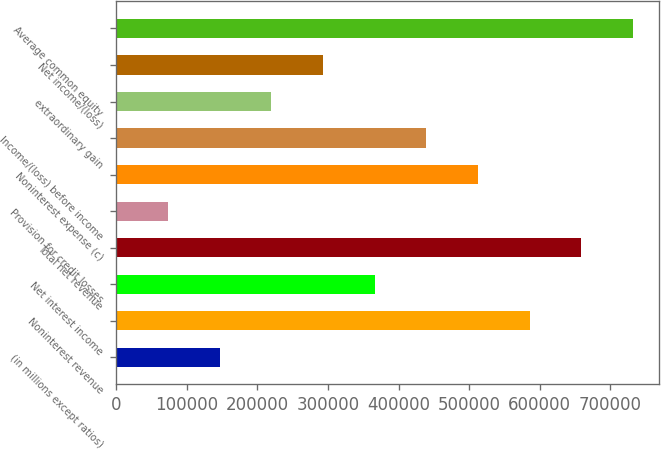<chart> <loc_0><loc_0><loc_500><loc_500><bar_chart><fcel>(in millions except ratios)<fcel>Noninterest revenue<fcel>Net interest income<fcel>Total net revenue<fcel>Provision for credit losses<fcel>Noninterest expense (c)<fcel>Income/(loss) before income<fcel>extraordinary gain<fcel>Net income/(loss)<fcel>Average common equity<nl><fcel>146413<fcel>585454<fcel>365934<fcel>658628<fcel>73239.5<fcel>512280<fcel>439107<fcel>219586<fcel>292760<fcel>731801<nl></chart> 